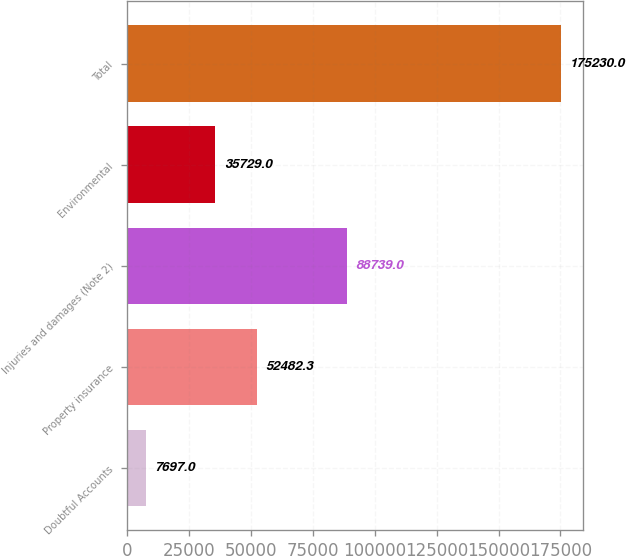Convert chart. <chart><loc_0><loc_0><loc_500><loc_500><bar_chart><fcel>Doubtful Accounts<fcel>Property insurance<fcel>Injuries and damages (Note 2)<fcel>Environmental<fcel>Total<nl><fcel>7697<fcel>52482.3<fcel>88739<fcel>35729<fcel>175230<nl></chart> 